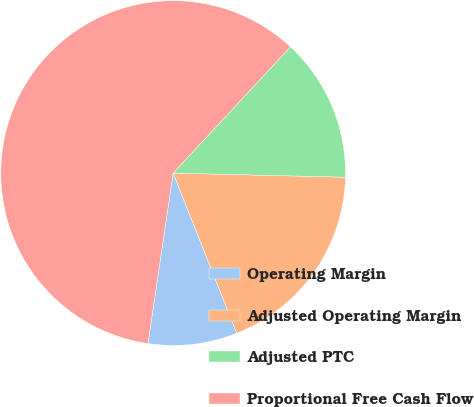<chart> <loc_0><loc_0><loc_500><loc_500><pie_chart><fcel>Operating Margin<fcel>Adjusted Operating Margin<fcel>Adjusted PTC<fcel>Proportional Free Cash Flow<nl><fcel>8.35%<fcel>18.6%<fcel>13.47%<fcel>59.58%<nl></chart> 